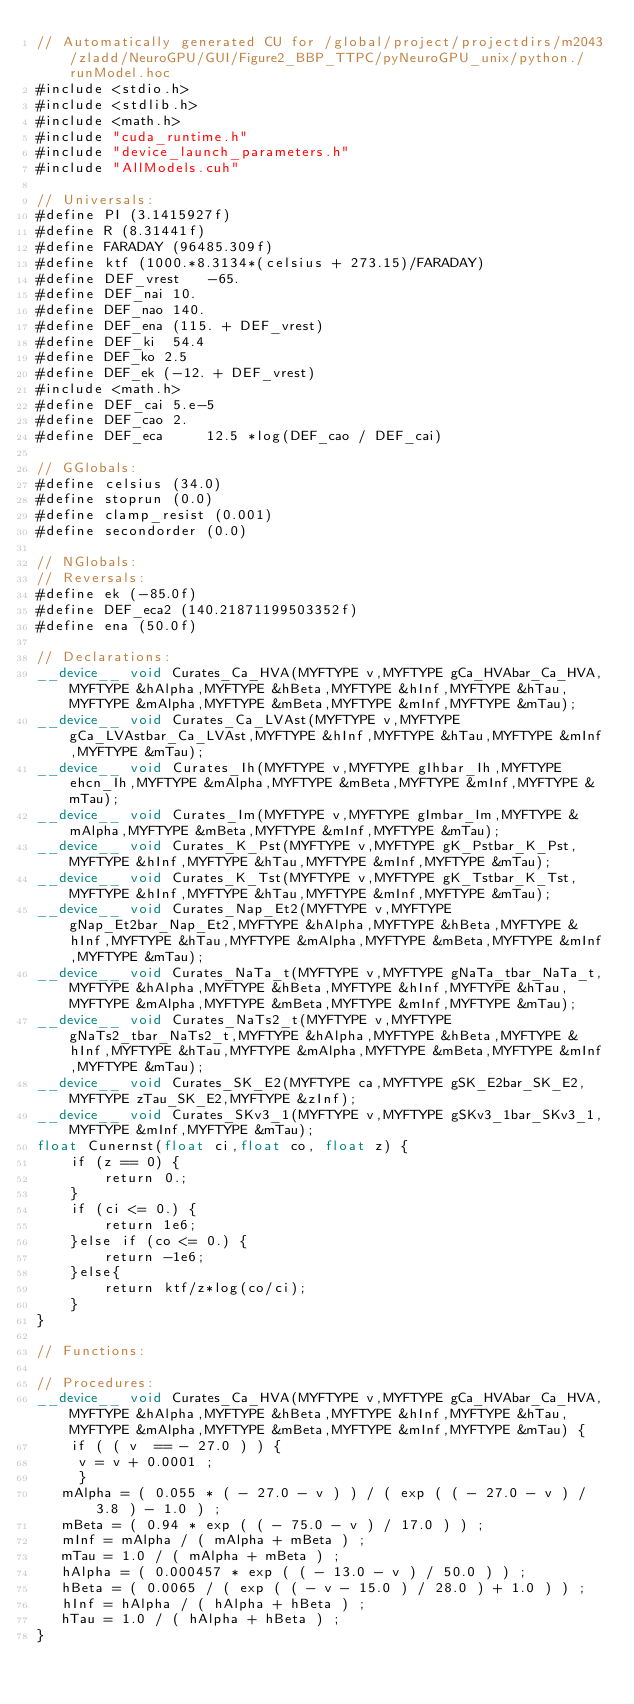Convert code to text. <code><loc_0><loc_0><loc_500><loc_500><_Cuda_>// Automatically generated CU for /global/project/projectdirs/m2043/zladd/NeuroGPU/GUI/Figure2_BBP_TTPC/pyNeuroGPU_unix/python./runModel.hoc
#include <stdio.h>
#include <stdlib.h>
#include <math.h>
#include "cuda_runtime.h"
#include "device_launch_parameters.h"
#include "AllModels.cuh"

// Universals:
#define PI (3.1415927f)
#define R (8.31441f)
#define FARADAY (96485.309f)
#define ktf (1000.*8.3134*(celsius + 273.15)/FARADAY)
#define DEF_vrest	-65.
#define DEF_nai 10.
#define DEF_nao 140.
#define DEF_ena (115. + DEF_vrest)
#define DEF_ki	54.4
#define DEF_ko 2.5
#define DEF_ek (-12. + DEF_vrest)
#include <math.h>
#define DEF_cai	5.e-5
#define DEF_cao	2.
#define	DEF_eca		12.5 *log(DEF_cao / DEF_cai)

// GGlobals:
#define celsius (34.0)
#define stoprun (0.0)
#define clamp_resist (0.001)
#define secondorder (0.0)

// NGlobals:
// Reversals:
#define ek (-85.0f)
#define DEF_eca2 (140.21871199503352f)
#define ena (50.0f)

// Declarations:
__device__ void Curates_Ca_HVA(MYFTYPE v,MYFTYPE gCa_HVAbar_Ca_HVA,MYFTYPE &hAlpha,MYFTYPE &hBeta,MYFTYPE &hInf,MYFTYPE &hTau,MYFTYPE &mAlpha,MYFTYPE &mBeta,MYFTYPE &mInf,MYFTYPE &mTau);
__device__ void Curates_Ca_LVAst(MYFTYPE v,MYFTYPE gCa_LVAstbar_Ca_LVAst,MYFTYPE &hInf,MYFTYPE &hTau,MYFTYPE &mInf,MYFTYPE &mTau);
__device__ void Curates_Ih(MYFTYPE v,MYFTYPE gIhbar_Ih,MYFTYPE ehcn_Ih,MYFTYPE &mAlpha,MYFTYPE &mBeta,MYFTYPE &mInf,MYFTYPE &mTau);
__device__ void Curates_Im(MYFTYPE v,MYFTYPE gImbar_Im,MYFTYPE &mAlpha,MYFTYPE &mBeta,MYFTYPE &mInf,MYFTYPE &mTau);
__device__ void Curates_K_Pst(MYFTYPE v,MYFTYPE gK_Pstbar_K_Pst,MYFTYPE &hInf,MYFTYPE &hTau,MYFTYPE &mInf,MYFTYPE &mTau);
__device__ void Curates_K_Tst(MYFTYPE v,MYFTYPE gK_Tstbar_K_Tst,MYFTYPE &hInf,MYFTYPE &hTau,MYFTYPE &mInf,MYFTYPE &mTau);
__device__ void Curates_Nap_Et2(MYFTYPE v,MYFTYPE gNap_Et2bar_Nap_Et2,MYFTYPE &hAlpha,MYFTYPE &hBeta,MYFTYPE &hInf,MYFTYPE &hTau,MYFTYPE &mAlpha,MYFTYPE &mBeta,MYFTYPE &mInf,MYFTYPE &mTau);
__device__ void Curates_NaTa_t(MYFTYPE v,MYFTYPE gNaTa_tbar_NaTa_t,MYFTYPE &hAlpha,MYFTYPE &hBeta,MYFTYPE &hInf,MYFTYPE &hTau,MYFTYPE &mAlpha,MYFTYPE &mBeta,MYFTYPE &mInf,MYFTYPE &mTau);
__device__ void Curates_NaTs2_t(MYFTYPE v,MYFTYPE gNaTs2_tbar_NaTs2_t,MYFTYPE &hAlpha,MYFTYPE &hBeta,MYFTYPE &hInf,MYFTYPE &hTau,MYFTYPE &mAlpha,MYFTYPE &mBeta,MYFTYPE &mInf,MYFTYPE &mTau);
__device__ void Curates_SK_E2(MYFTYPE ca,MYFTYPE gSK_E2bar_SK_E2,MYFTYPE zTau_SK_E2,MYFTYPE &zInf);
__device__ void Curates_SKv3_1(MYFTYPE v,MYFTYPE gSKv3_1bar_SKv3_1,MYFTYPE &mInf,MYFTYPE &mTau);
float Cunernst(float ci,float co, float z) {
	if (z == 0) {
		return 0.;
	}
	if (ci <= 0.) {
		return 1e6;
	}else if (co <= 0.) {
		return -1e6;
	}else{
		return ktf/z*log(co/ci);
	}	
}

// Functions:

// Procedures:
__device__ void Curates_Ca_HVA(MYFTYPE v,MYFTYPE gCa_HVAbar_Ca_HVA,MYFTYPE &hAlpha,MYFTYPE &hBeta,MYFTYPE &hInf,MYFTYPE &hTau,MYFTYPE &mAlpha,MYFTYPE &mBeta,MYFTYPE &mInf,MYFTYPE &mTau) {
    if ( ( v  == - 27.0 ) ) {
     v = v + 0.0001 ;
     }
   mAlpha = ( 0.055 * ( - 27.0 - v ) ) / ( exp ( ( - 27.0 - v ) / 3.8 ) - 1.0 ) ;
   mBeta = ( 0.94 * exp ( ( - 75.0 - v ) / 17.0 ) ) ;
   mInf = mAlpha / ( mAlpha + mBeta ) ;
   mTau = 1.0 / ( mAlpha + mBeta ) ;
   hAlpha = ( 0.000457 * exp ( ( - 13.0 - v ) / 50.0 ) ) ;
   hBeta = ( 0.0065 / ( exp ( ( - v - 15.0 ) / 28.0 ) + 1.0 ) ) ;
   hInf = hAlpha / ( hAlpha + hBeta ) ;
   hTau = 1.0 / ( hAlpha + hBeta ) ;
}</code> 